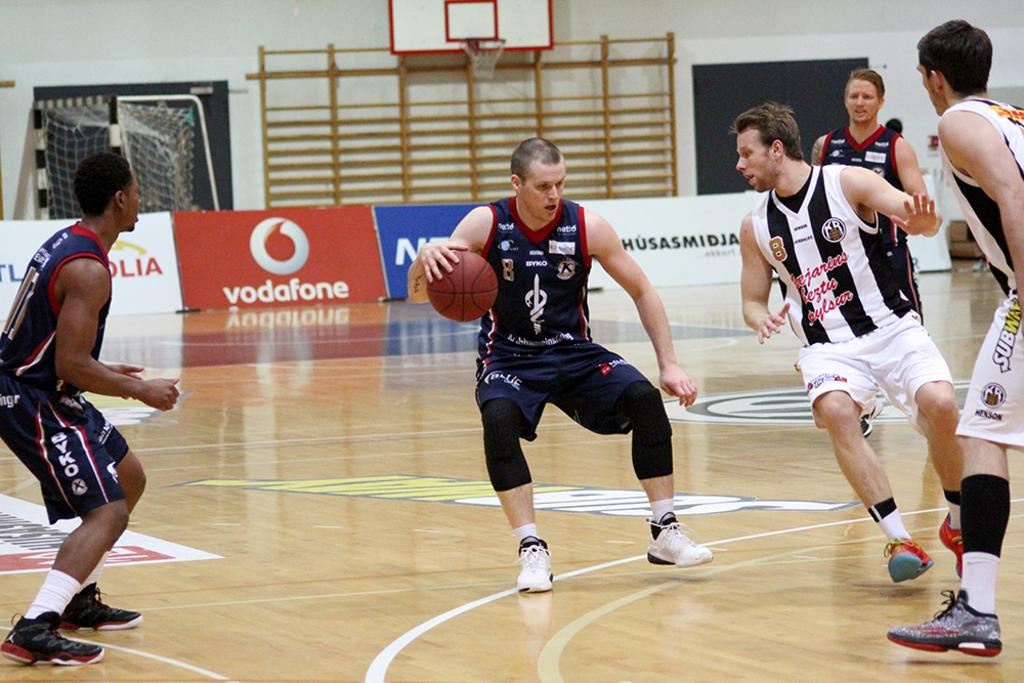<image>
Create a compact narrative representing the image presented. Men are playing basketball and on the sidelines there is an ad for vodaphone. 